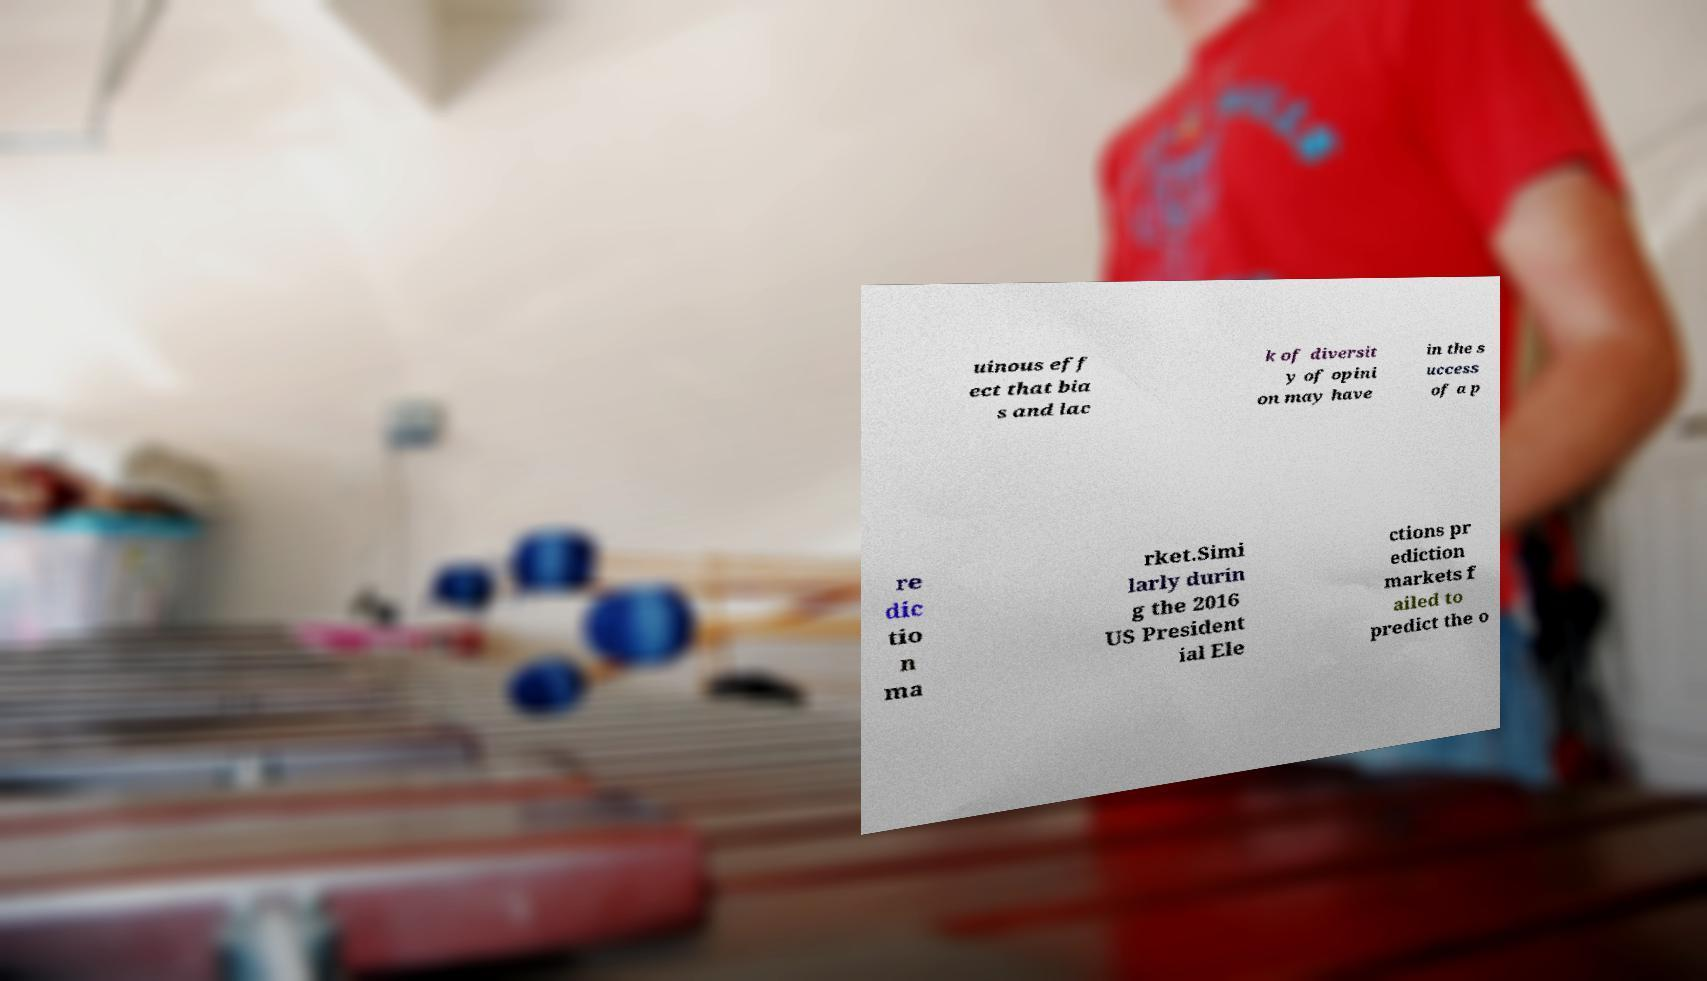I need the written content from this picture converted into text. Can you do that? uinous eff ect that bia s and lac k of diversit y of opini on may have in the s uccess of a p re dic tio n ma rket.Simi larly durin g the 2016 US President ial Ele ctions pr ediction markets f ailed to predict the o 